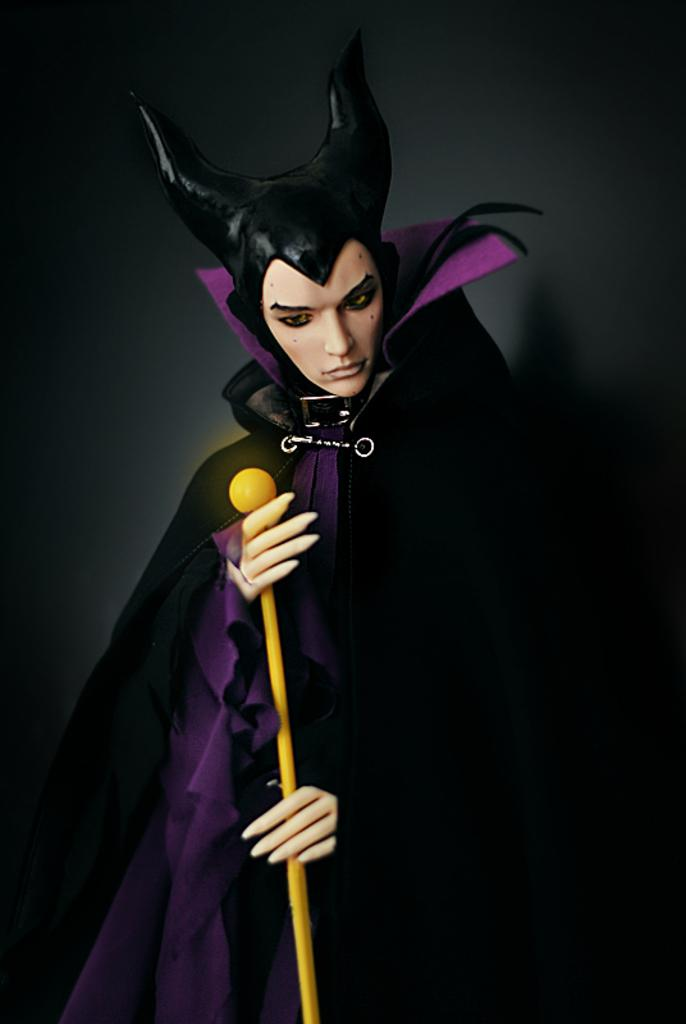What is the main subject of the image? The main subject of the image is a statue of a woman. What is the woman holding in the image? The woman is holding a stick in the image. What can be observed about the background of the image? The background of the image is dark in color. What is the answer to the math problem written on the statue's base in the image? There is no math problem or answer written on the statue's base in the image. 